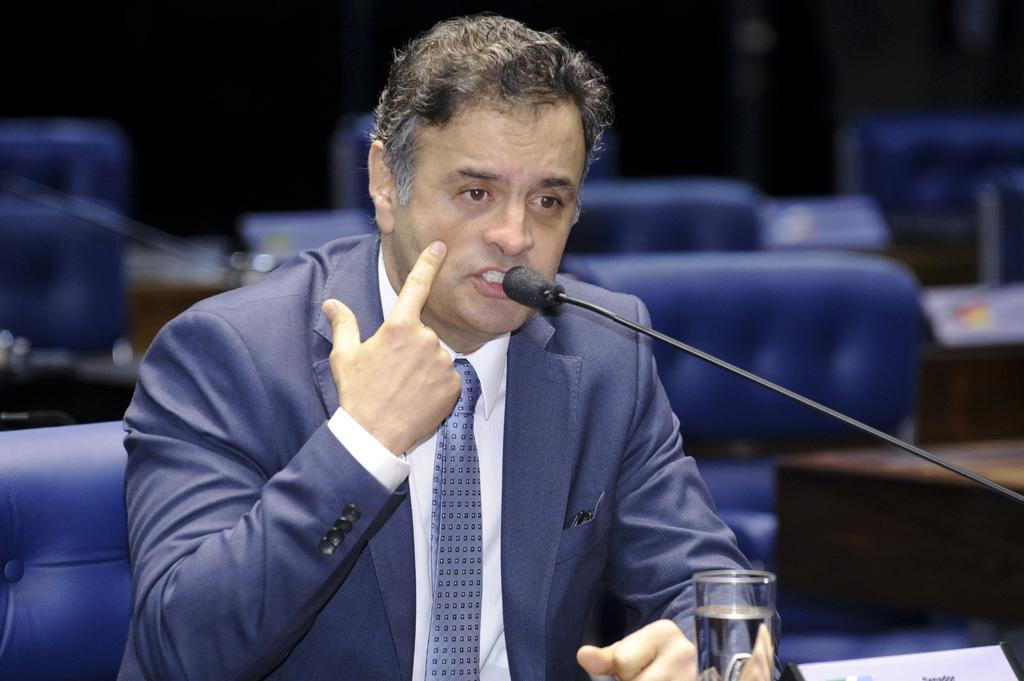Who is the main subject in the image? There is a man in the center of the image. What is the man holding or using in the image? The man is holding a mic in front of him. What is placed next to the mic in the image? There is a glass of water in front of the man. What can be seen behind the man in the image? There are chairs behind the man. What type of stream is visible in the background of the image? There is no stream visible in the background of the image. 